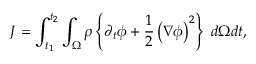Convert formula to latex. <formula><loc_0><loc_0><loc_500><loc_500>J = \int _ { t _ { 1 } } ^ { t _ { 2 } } \int _ { \Omega } \rho \left \{ \partial _ { t } \phi + \frac { 1 } { 2 } \left ( \nabla \phi \right ) ^ { 2 } \right \} \, d \Omega d t ,</formula> 